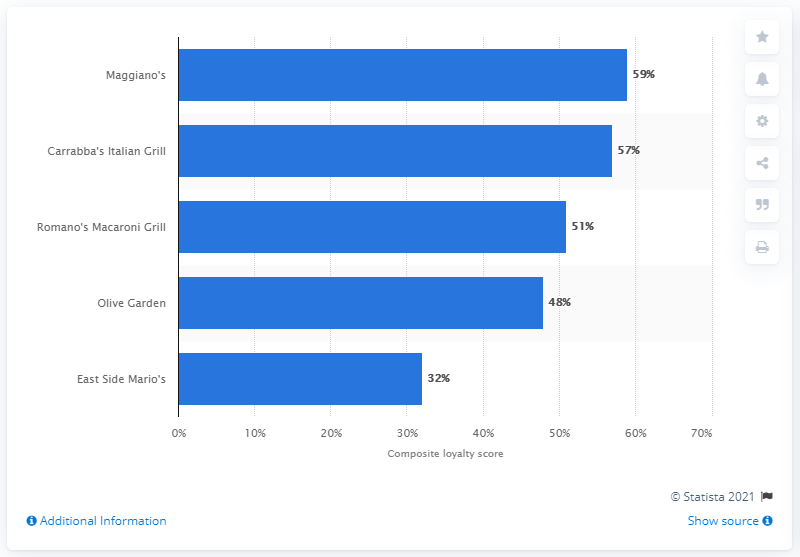Highlight a few significant elements in this photo. In April 2014, Maggiano's was the most popular Italian restaurant chain in North America. 